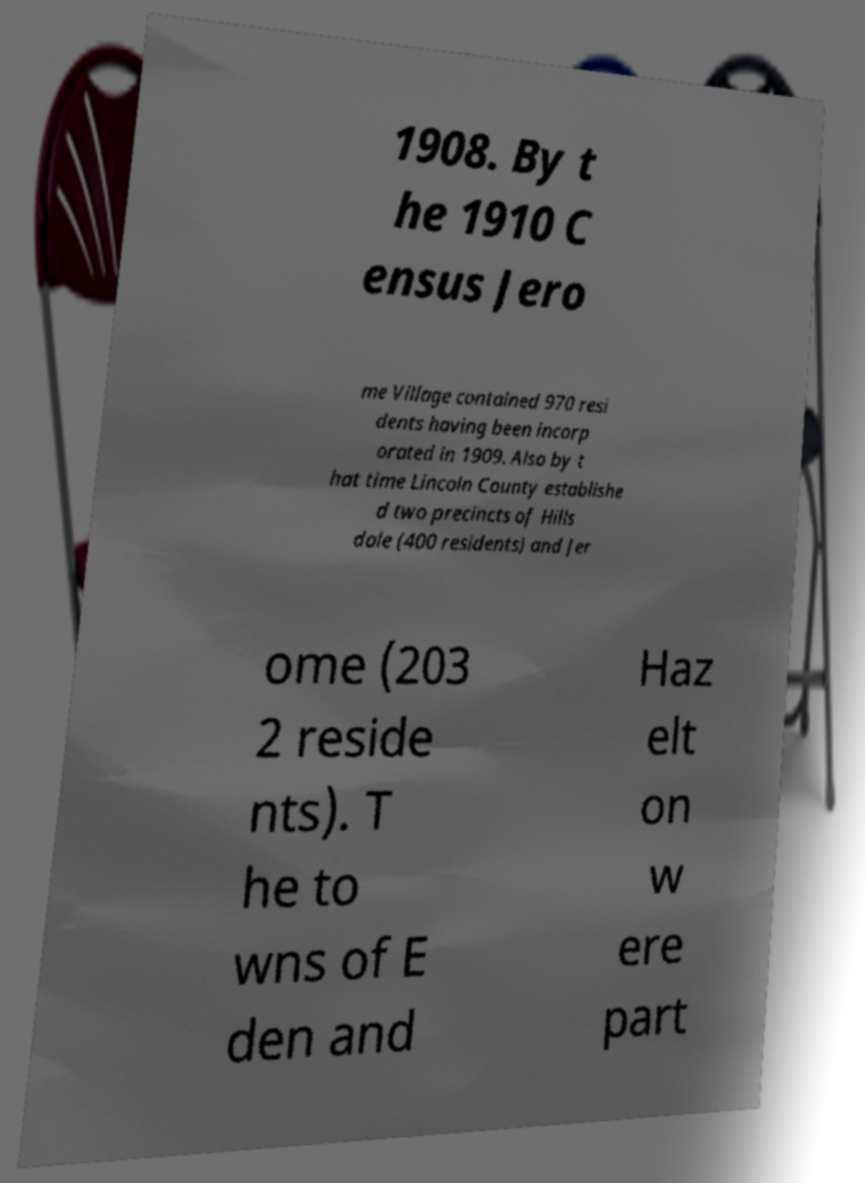Please identify and transcribe the text found in this image. 1908. By t he 1910 C ensus Jero me Village contained 970 resi dents having been incorp orated in 1909. Also by t hat time Lincoln County establishe d two precincts of Hills dale (400 residents) and Jer ome (203 2 reside nts). T he to wns of E den and Haz elt on w ere part 